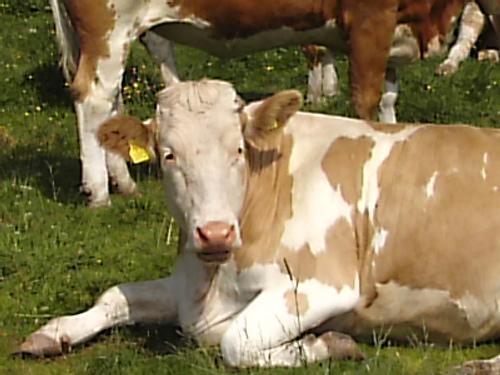How many cows are there?
Give a very brief answer. 3. 